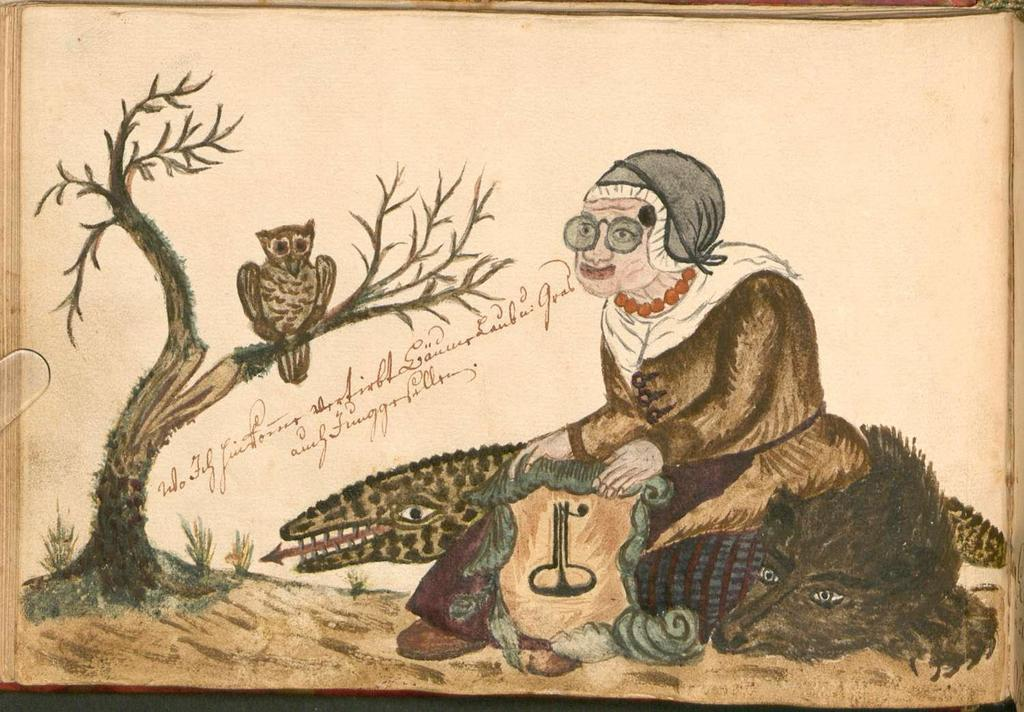Who is the main subject of the painting? The painting depicts a woman. What animals are present in the painting? There are crocodiles and an owl in the painting. What type of plant can be seen in the painting? There is a tree in the painting. What type of apparel is the woman wearing in the painting? The provided facts do not mention any specific apparel worn by the woman in the painting. --- Facts: 1. There is a car in the image. 2. The car is red. 3. The car has four wheels. 4. There is a road in the image. 5. The road is paved. Absurd Topics: topics: bird, ocean, mountain Conversation: What is the main subject of the image? The main subject of the image is a car. What color is the car? The car is red. How many wheels does the car have? The car has four wheels. What type of surface can be seen in the image? There is a road in the image, and it is paved. Reasoning: Let's think step by step in order to produce the conversation. We start by identifying the main subject of the image, which is the car. Then, we describe the color and number of wheels of the car, as mentioned in the facts. Finally, we describe the type of surface that can be seen in the image, which is a paved road. Each question is designed to elicit a specific detail about the image that is known from the provided facts. Absurd Question/Answer: Can you see any mountains in the image? There are no mountains present in the image; it features a red car and a paved road. 